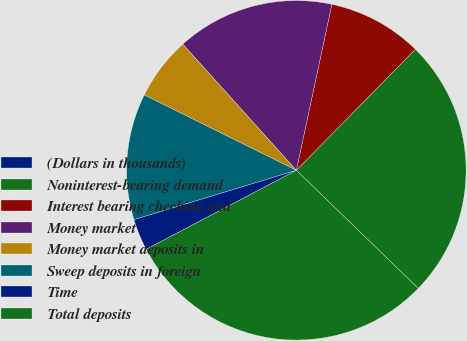Convert chart to OTSL. <chart><loc_0><loc_0><loc_500><loc_500><pie_chart><fcel>(Dollars in thousands)<fcel>Noninterest-bearing demand<fcel>Interest bearing checking and<fcel>Money market<fcel>Money market deposits in<fcel>Sweep deposits in foreign<fcel>Time<fcel>Total deposits<nl><fcel>0.0%<fcel>24.88%<fcel>9.01%<fcel>15.02%<fcel>6.01%<fcel>12.02%<fcel>3.01%<fcel>30.04%<nl></chart> 